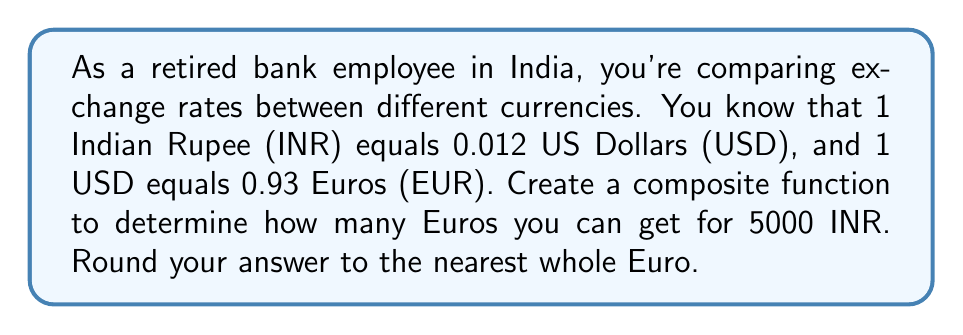Help me with this question. Let's approach this step-by-step:

1) First, let's define our functions:
   $f(x) = 0.012x$ (converts INR to USD)
   $g(x) = 0.93x$ (converts USD to EUR)

2) We need to compose these functions to convert directly from INR to EUR:
   $(g \circ f)(x) = g(f(x)) = 0.93(0.012x) = 0.0112x$

3) This composite function $(g \circ f)(x)$ now converts directly from INR to EUR.

4) To find out how many Euros we can get for 5000 INR, we evaluate:
   $(g \circ f)(5000) = 0.0112 \times 5000 = 56$

5) Rounding to the nearest whole Euro:
   $56$ EUR

Therefore, 5000 INR can be exchanged for approximately 56 EUR.
Answer: 56 EUR 